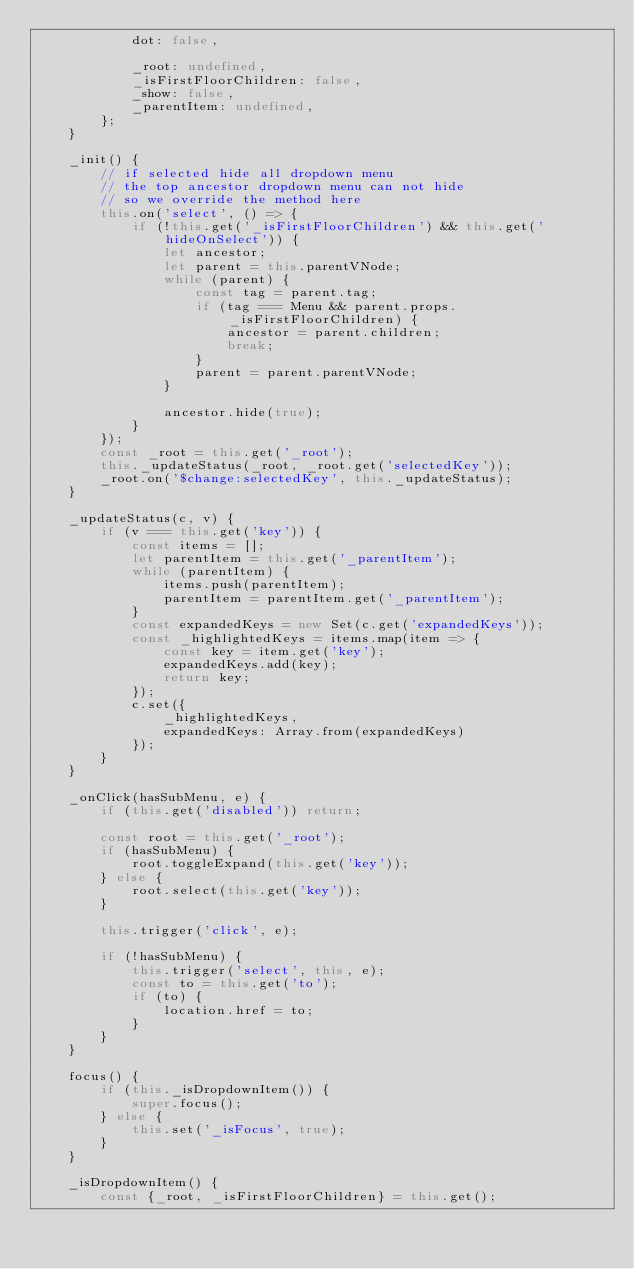Convert code to text. <code><loc_0><loc_0><loc_500><loc_500><_JavaScript_>            dot: false,

            _root: undefined,
            _isFirstFloorChildren: false,
            _show: false,
            _parentItem: undefined,
        };
    }

    _init() {
        // if selected hide all dropdown menu
        // the top ancestor dropdown menu can not hide
        // so we override the method here
        this.on('select', () => {
            if (!this.get('_isFirstFloorChildren') && this.get('hideOnSelect')) {
                let ancestor;
                let parent = this.parentVNode;
                while (parent) {
                    const tag = parent.tag;
                    if (tag === Menu && parent.props._isFirstFloorChildren) {
                        ancestor = parent.children;        
                        break;
                    }
                    parent = parent.parentVNode;
                }

                ancestor.hide(true);
            }
        });
        const _root = this.get('_root');
        this._updateStatus(_root, _root.get('selectedKey'));
        _root.on('$change:selectedKey', this._updateStatus);
    }

    _updateStatus(c, v) {
        if (v === this.get('key')) {
            const items = [];
            let parentItem = this.get('_parentItem');
            while (parentItem) {
                items.push(parentItem);
                parentItem = parentItem.get('_parentItem');
            }
            const expandedKeys = new Set(c.get('expandedKeys'));
            const _highlightedKeys = items.map(item => {
                const key = item.get('key');
                expandedKeys.add(key);
                return key;
            });
            c.set({
                _highlightedKeys,
                expandedKeys: Array.from(expandedKeys)
            });
        }
    }

    _onClick(hasSubMenu, e) {
        if (this.get('disabled')) return;

        const root = this.get('_root');
        if (hasSubMenu) {
            root.toggleExpand(this.get('key'));
        } else {
            root.select(this.get('key'));
        }

        this.trigger('click', e);

        if (!hasSubMenu) {
            this.trigger('select', this, e);
            const to = this.get('to');
            if (to) {
                location.href = to;
            }
        }
    }

    focus() {
        if (this._isDropdownItem()) {
            super.focus();
        } else {
            this.set('_isFocus', true);
        }
    }

    _isDropdownItem() {
        const {_root, _isFirstFloorChildren} = this.get();</code> 